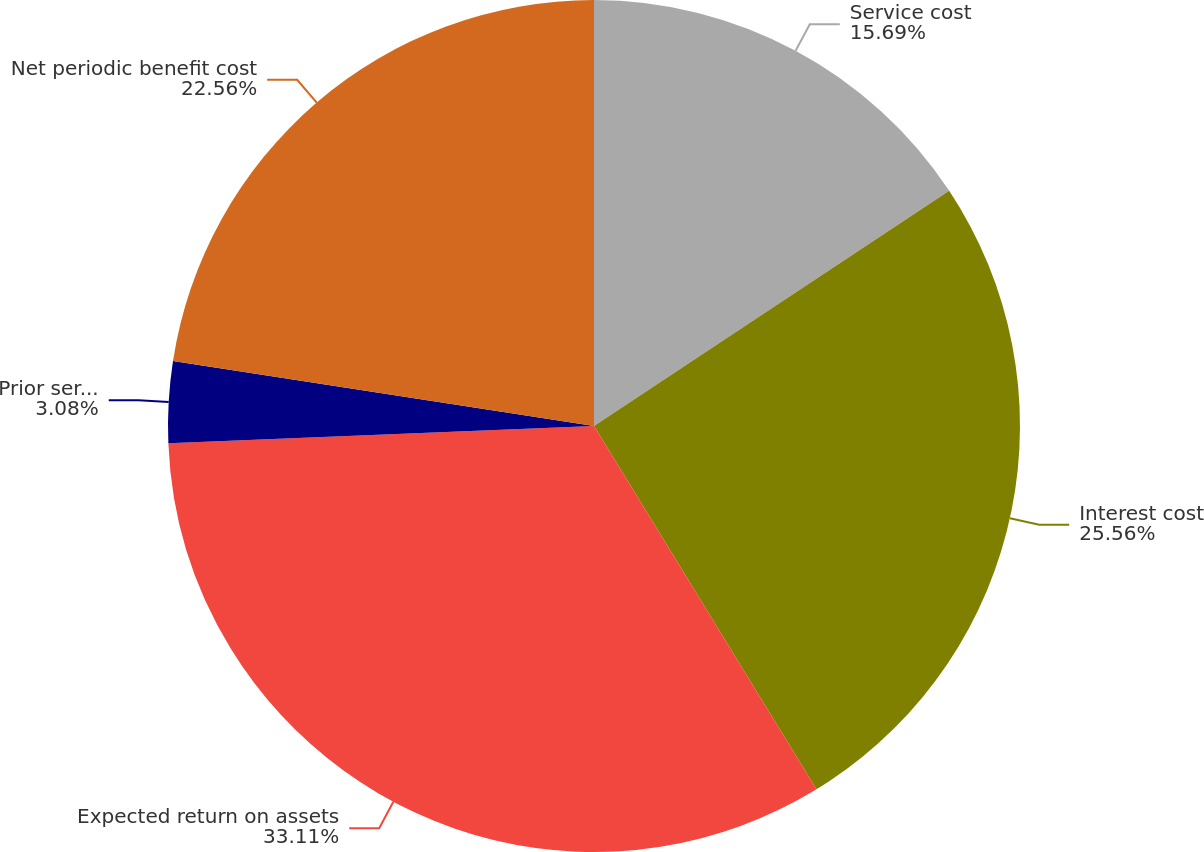Convert chart. <chart><loc_0><loc_0><loc_500><loc_500><pie_chart><fcel>Service cost<fcel>Interest cost<fcel>Expected return on assets<fcel>Prior service cost<fcel>Net periodic benefit cost<nl><fcel>15.69%<fcel>25.56%<fcel>33.1%<fcel>3.08%<fcel>22.56%<nl></chart> 